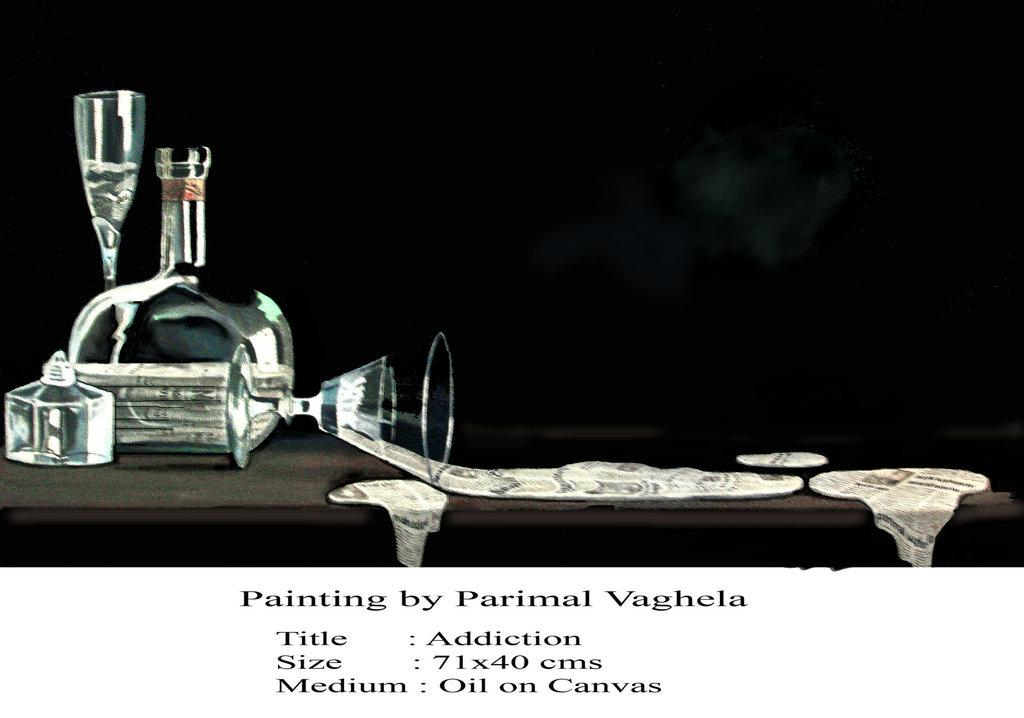What type of container is visible in the image? There is a glass flask in the image. What other object can be seen in the image? There is a wine glass in the image. Where is the painting located in the image? The painting is on a table in the image. Who is the artist of the painting? The text "painting by parimal vaghela" is written at the bottom of the painting, indicating that Parimal Vaghela is the artist. How does the porter help with the trouble in the image? There is no porter or trouble present in the image; it features a painting with a glass flask and a wine glass. What change occurs in the image after the artist finishes painting? There is no change that occurs in the image after the artist finishes painting, as the image is a static representation of the objects and the painting itself. 